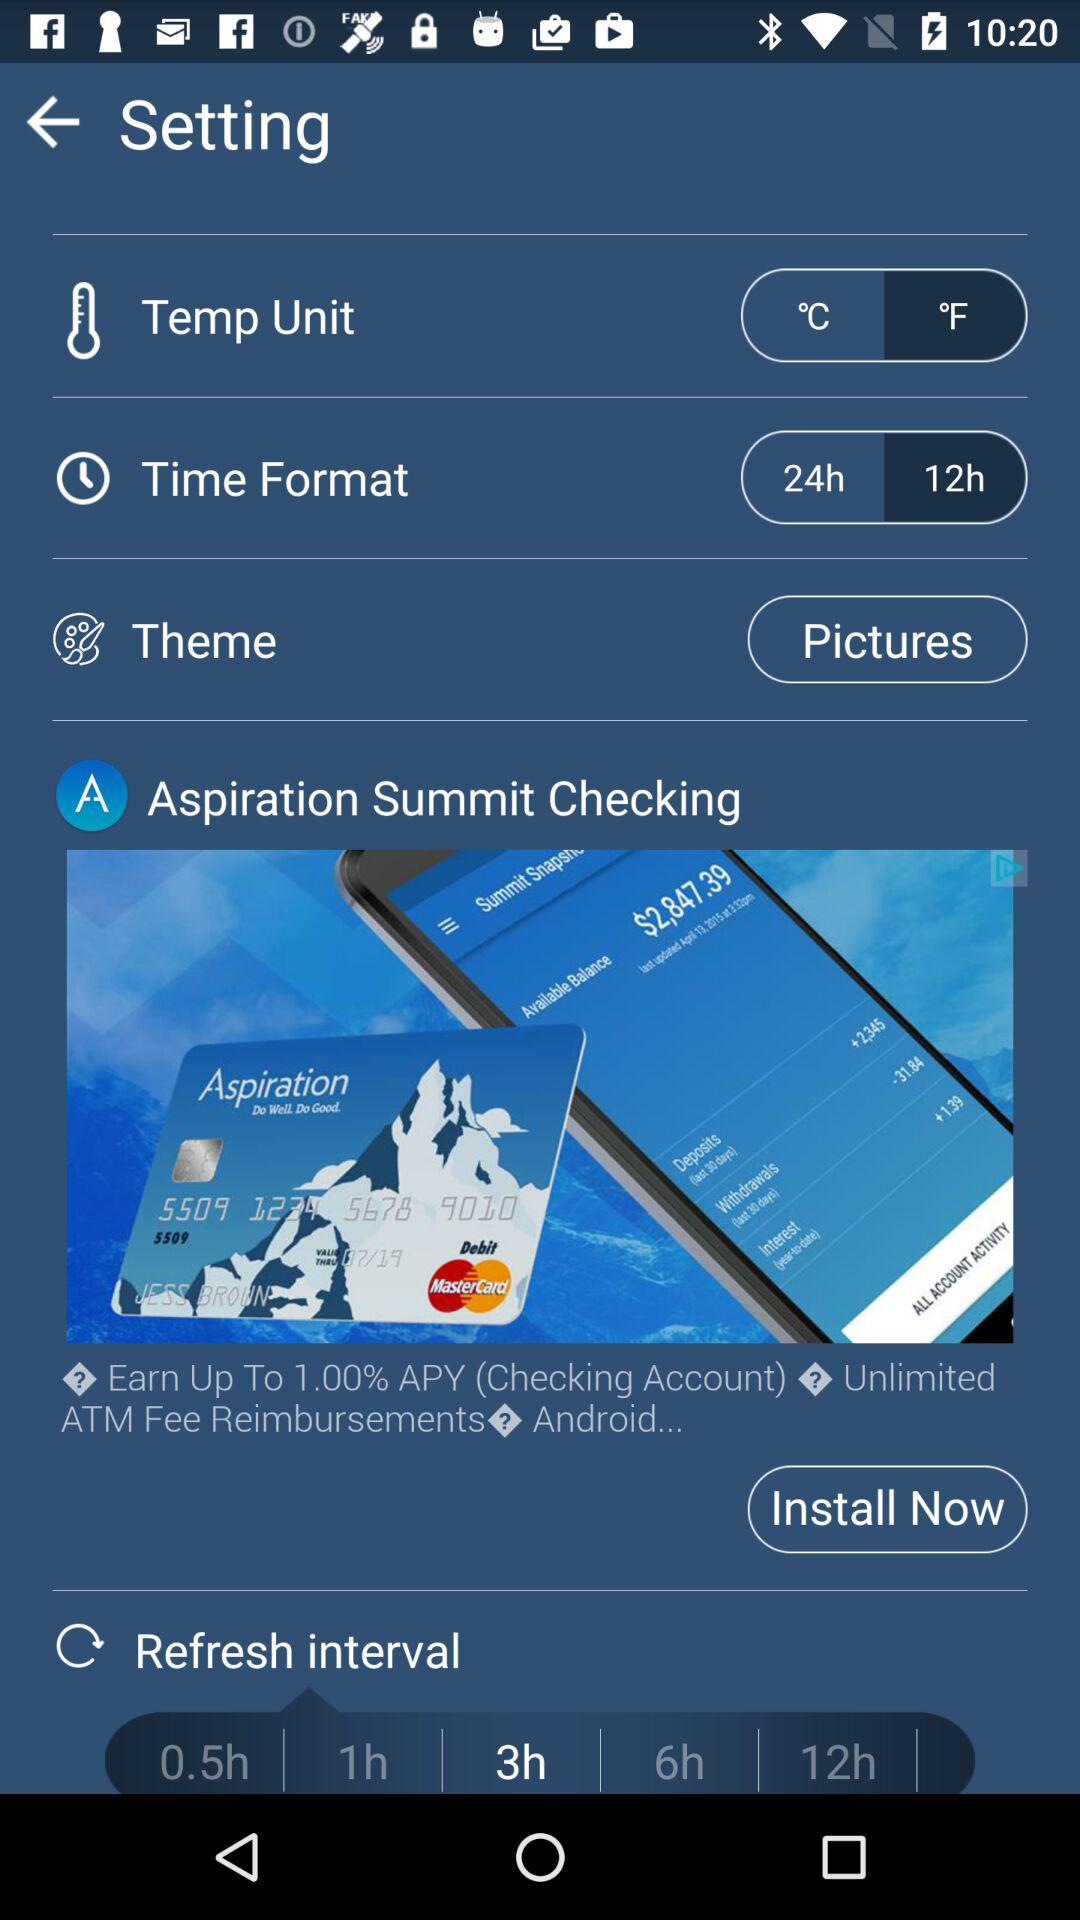What theme is selected? The selected theme is "Pictures". 